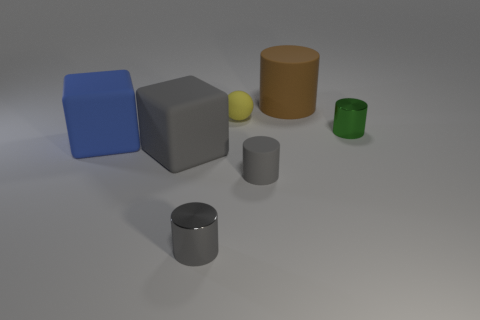Subtract all brown cylinders. How many cylinders are left? 3 Add 1 small rubber blocks. How many objects exist? 8 Subtract all cyan cylinders. Subtract all yellow cubes. How many cylinders are left? 4 Subtract all blocks. How many objects are left? 5 Add 5 gray cubes. How many gray cubes exist? 6 Subtract 1 gray cubes. How many objects are left? 6 Subtract all big brown rubber cylinders. Subtract all large gray matte cubes. How many objects are left? 5 Add 1 brown matte objects. How many brown matte objects are left? 2 